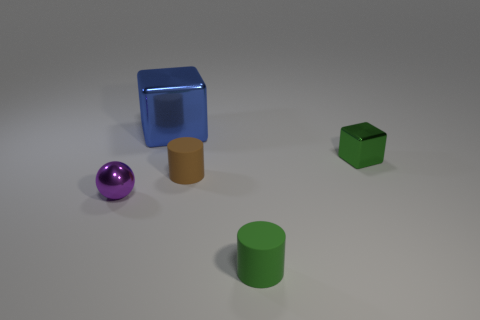Subtract all brown cylinders. How many cylinders are left? 1 Add 2 blue objects. How many objects exist? 7 Subtract all cylinders. How many objects are left? 3 Subtract 0 cyan cubes. How many objects are left? 5 Subtract all red cubes. Subtract all cyan cylinders. How many cubes are left? 2 Subtract all blue spheres. How many cyan cylinders are left? 0 Subtract all green rubber cylinders. Subtract all small purple spheres. How many objects are left? 3 Add 2 big cubes. How many big cubes are left? 3 Add 3 large yellow rubber cylinders. How many large yellow rubber cylinders exist? 3 